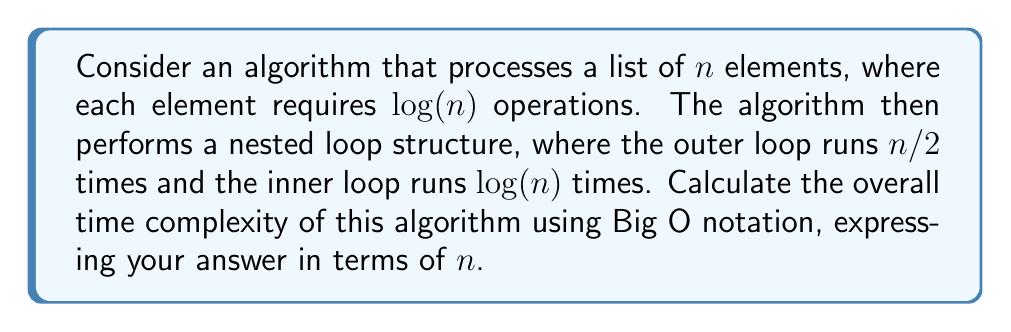Could you help me with this problem? Let's break down the algorithm and analyze its time complexity step by step:

1. Processing each element:
   - Number of elements: $n$
   - Operations per element: $\log(n)$
   - Total operations: $n \cdot \log(n)$

2. Nested loop structure:
   - Outer loop runs $n/2$ times
   - Inner loop runs $\log(n)$ times
   - Total iterations: $\frac{n}{2} \cdot \log(n)$

3. Combining the complexities:
   - Total time complexity: $T(n) = n \cdot \log(n) + \frac{n}{2} \cdot \log(n)$

4. Simplifying:
   $$T(n) = n \cdot \log(n) + \frac{n}{2} \cdot \log(n)$$
   $$= n \cdot \log(n) + 0.5n \cdot \log(n)$$
   $$= 1.5n \cdot \log(n)$$

5. Applying Big O notation:
   - Constants are dropped in Big O notation
   - $O(1.5n \cdot \log(n))$ simplifies to $O(n \cdot \log(n))$

Therefore, the overall time complexity of the algorithm is $O(n \log n)$.
Answer: $O(n \log n)$ 